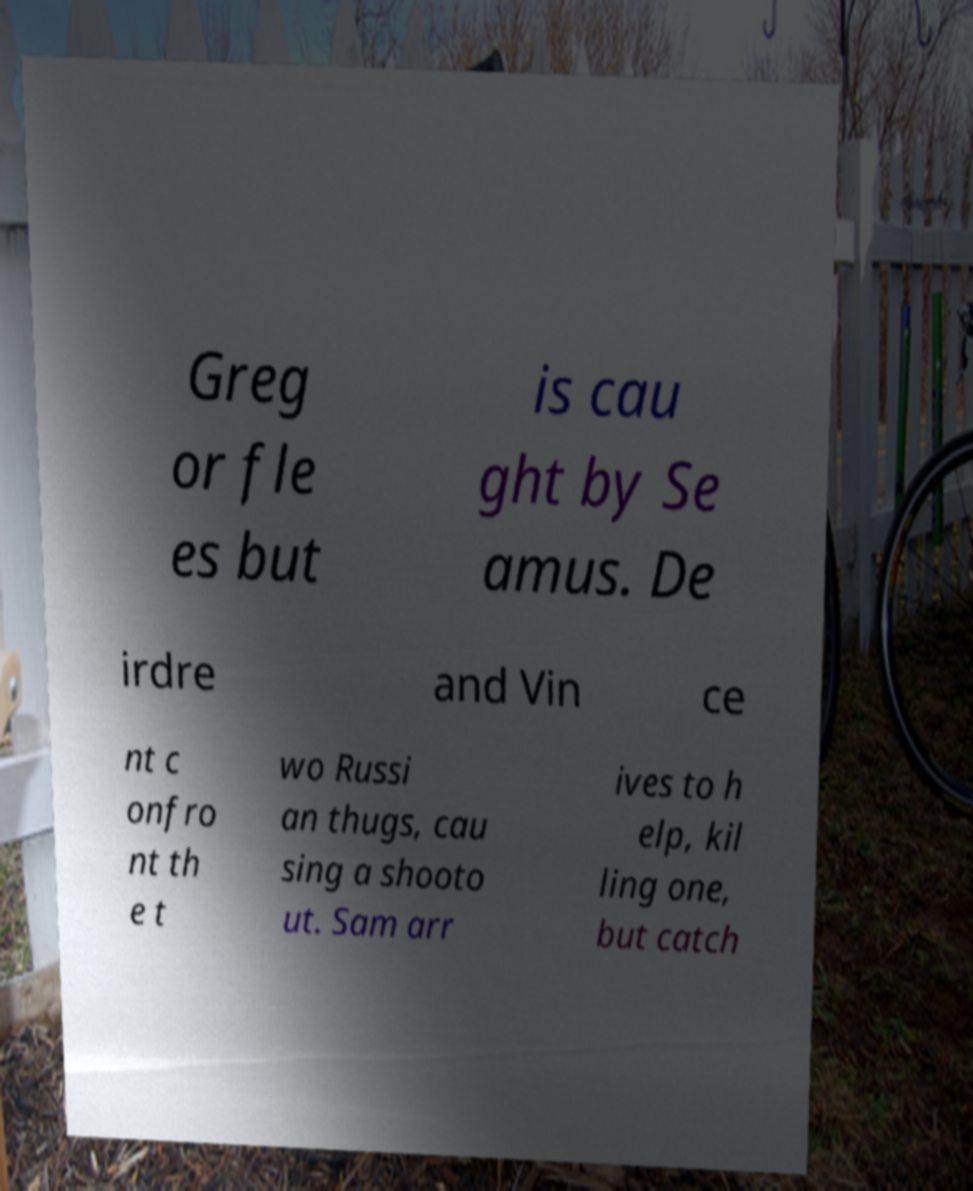Please identify and transcribe the text found in this image. Greg or fle es but is cau ght by Se amus. De irdre and Vin ce nt c onfro nt th e t wo Russi an thugs, cau sing a shooto ut. Sam arr ives to h elp, kil ling one, but catch 